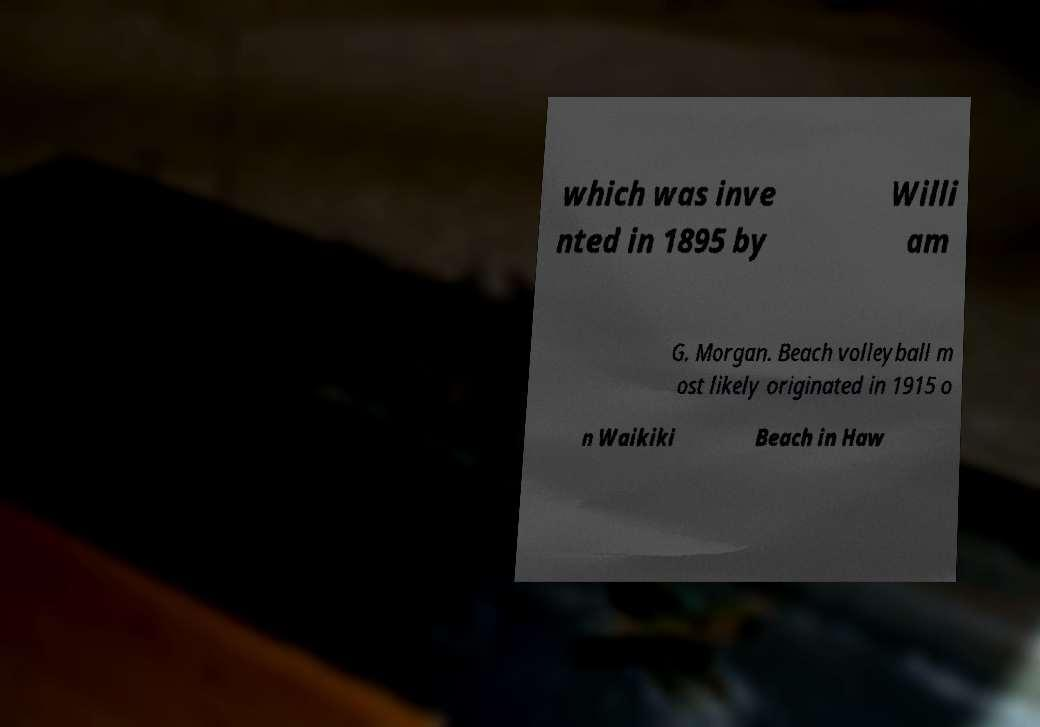Could you assist in decoding the text presented in this image and type it out clearly? which was inve nted in 1895 by Willi am G. Morgan. Beach volleyball m ost likely originated in 1915 o n Waikiki Beach in Haw 